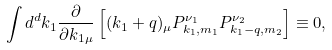Convert formula to latex. <formula><loc_0><loc_0><loc_500><loc_500>\int d ^ { d } k _ { 1 } \frac { \partial } { \partial k _ { 1 \mu } } \left [ ( k _ { 1 } + q ) _ { \mu } P _ { k _ { 1 } , m _ { 1 } } ^ { \nu _ { 1 } } P _ { k _ { 1 } - q , m _ { 2 } } ^ { \nu _ { 2 } } \right ] \equiv 0 ,</formula> 